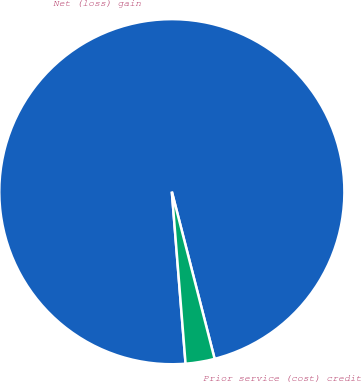<chart> <loc_0><loc_0><loc_500><loc_500><pie_chart><fcel>Net (loss) gain<fcel>Prior service (cost) credit<nl><fcel>97.28%<fcel>2.72%<nl></chart> 